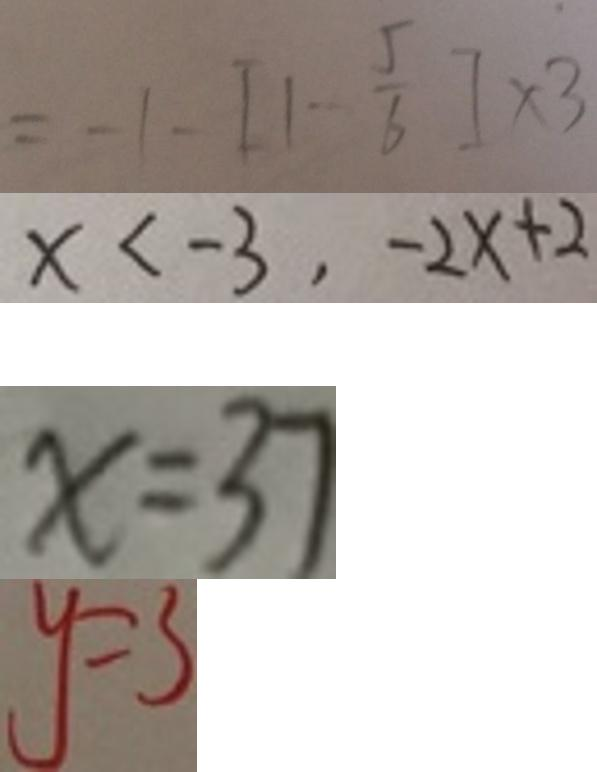<formula> <loc_0><loc_0><loc_500><loc_500>= - 1 - [ 1 - \frac { 5 } { 6 } ] \times 3 
 x < - 3 , - 2 x + 2 
 x = 3 7 
 y = 3</formula> 